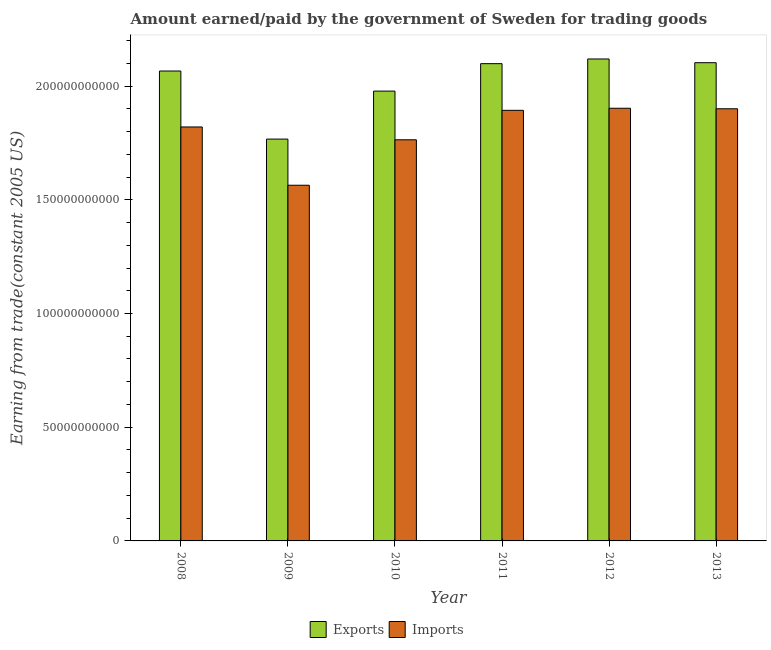How many different coloured bars are there?
Ensure brevity in your answer.  2. How many bars are there on the 5th tick from the right?
Your answer should be compact. 2. What is the label of the 6th group of bars from the left?
Keep it short and to the point. 2013. What is the amount earned from exports in 2010?
Give a very brief answer. 1.98e+11. Across all years, what is the maximum amount earned from exports?
Your answer should be very brief. 2.12e+11. Across all years, what is the minimum amount earned from exports?
Offer a very short reply. 1.77e+11. In which year was the amount earned from exports minimum?
Ensure brevity in your answer.  2009. What is the total amount earned from exports in the graph?
Make the answer very short. 1.21e+12. What is the difference between the amount earned from exports in 2011 and that in 2012?
Give a very brief answer. -2.06e+09. What is the difference between the amount paid for imports in 2012 and the amount earned from exports in 2009?
Make the answer very short. 3.39e+1. What is the average amount paid for imports per year?
Provide a succinct answer. 1.81e+11. In the year 2010, what is the difference between the amount paid for imports and amount earned from exports?
Give a very brief answer. 0. In how many years, is the amount paid for imports greater than 140000000000 US$?
Offer a terse response. 6. What is the ratio of the amount earned from exports in 2008 to that in 2009?
Ensure brevity in your answer.  1.17. Is the difference between the amount paid for imports in 2012 and 2013 greater than the difference between the amount earned from exports in 2012 and 2013?
Make the answer very short. No. What is the difference between the highest and the second highest amount paid for imports?
Provide a succinct answer. 2.25e+08. What is the difference between the highest and the lowest amount paid for imports?
Give a very brief answer. 3.39e+1. In how many years, is the amount paid for imports greater than the average amount paid for imports taken over all years?
Make the answer very short. 4. Is the sum of the amount earned from exports in 2009 and 2010 greater than the maximum amount paid for imports across all years?
Your response must be concise. Yes. What does the 1st bar from the left in 2009 represents?
Give a very brief answer. Exports. What does the 2nd bar from the right in 2009 represents?
Offer a very short reply. Exports. How many bars are there?
Offer a very short reply. 12. Are all the bars in the graph horizontal?
Make the answer very short. No. How many years are there in the graph?
Give a very brief answer. 6. Are the values on the major ticks of Y-axis written in scientific E-notation?
Provide a succinct answer. No. Does the graph contain any zero values?
Provide a succinct answer. No. Does the graph contain grids?
Keep it short and to the point. No. Where does the legend appear in the graph?
Your response must be concise. Bottom center. What is the title of the graph?
Give a very brief answer. Amount earned/paid by the government of Sweden for trading goods. What is the label or title of the Y-axis?
Your answer should be compact. Earning from trade(constant 2005 US). What is the Earning from trade(constant 2005 US) in Exports in 2008?
Keep it short and to the point. 2.07e+11. What is the Earning from trade(constant 2005 US) of Imports in 2008?
Offer a very short reply. 1.82e+11. What is the Earning from trade(constant 2005 US) in Exports in 2009?
Ensure brevity in your answer.  1.77e+11. What is the Earning from trade(constant 2005 US) in Imports in 2009?
Your answer should be very brief. 1.56e+11. What is the Earning from trade(constant 2005 US) of Exports in 2010?
Provide a succinct answer. 1.98e+11. What is the Earning from trade(constant 2005 US) of Imports in 2010?
Make the answer very short. 1.76e+11. What is the Earning from trade(constant 2005 US) in Exports in 2011?
Give a very brief answer. 2.10e+11. What is the Earning from trade(constant 2005 US) of Imports in 2011?
Provide a short and direct response. 1.89e+11. What is the Earning from trade(constant 2005 US) in Exports in 2012?
Make the answer very short. 2.12e+11. What is the Earning from trade(constant 2005 US) in Imports in 2012?
Give a very brief answer. 1.90e+11. What is the Earning from trade(constant 2005 US) in Exports in 2013?
Your answer should be compact. 2.10e+11. What is the Earning from trade(constant 2005 US) of Imports in 2013?
Offer a very short reply. 1.90e+11. Across all years, what is the maximum Earning from trade(constant 2005 US) of Exports?
Offer a terse response. 2.12e+11. Across all years, what is the maximum Earning from trade(constant 2005 US) in Imports?
Your response must be concise. 1.90e+11. Across all years, what is the minimum Earning from trade(constant 2005 US) in Exports?
Provide a succinct answer. 1.77e+11. Across all years, what is the minimum Earning from trade(constant 2005 US) in Imports?
Provide a succinct answer. 1.56e+11. What is the total Earning from trade(constant 2005 US) in Exports in the graph?
Provide a short and direct response. 1.21e+12. What is the total Earning from trade(constant 2005 US) of Imports in the graph?
Provide a short and direct response. 1.08e+12. What is the difference between the Earning from trade(constant 2005 US) of Exports in 2008 and that in 2009?
Give a very brief answer. 2.99e+1. What is the difference between the Earning from trade(constant 2005 US) in Imports in 2008 and that in 2009?
Keep it short and to the point. 2.56e+1. What is the difference between the Earning from trade(constant 2005 US) of Exports in 2008 and that in 2010?
Ensure brevity in your answer.  8.83e+09. What is the difference between the Earning from trade(constant 2005 US) of Imports in 2008 and that in 2010?
Provide a short and direct response. 5.64e+09. What is the difference between the Earning from trade(constant 2005 US) in Exports in 2008 and that in 2011?
Provide a succinct answer. -3.24e+09. What is the difference between the Earning from trade(constant 2005 US) in Imports in 2008 and that in 2011?
Your answer should be very brief. -7.31e+09. What is the difference between the Earning from trade(constant 2005 US) in Exports in 2008 and that in 2012?
Make the answer very short. -5.30e+09. What is the difference between the Earning from trade(constant 2005 US) in Imports in 2008 and that in 2012?
Offer a very short reply. -8.23e+09. What is the difference between the Earning from trade(constant 2005 US) in Exports in 2008 and that in 2013?
Offer a very short reply. -3.66e+09. What is the difference between the Earning from trade(constant 2005 US) of Imports in 2008 and that in 2013?
Make the answer very short. -8.00e+09. What is the difference between the Earning from trade(constant 2005 US) of Exports in 2009 and that in 2010?
Keep it short and to the point. -2.11e+1. What is the difference between the Earning from trade(constant 2005 US) in Imports in 2009 and that in 2010?
Offer a terse response. -2.00e+1. What is the difference between the Earning from trade(constant 2005 US) of Exports in 2009 and that in 2011?
Your answer should be compact. -3.32e+1. What is the difference between the Earning from trade(constant 2005 US) in Imports in 2009 and that in 2011?
Give a very brief answer. -3.29e+1. What is the difference between the Earning from trade(constant 2005 US) in Exports in 2009 and that in 2012?
Give a very brief answer. -3.52e+1. What is the difference between the Earning from trade(constant 2005 US) in Imports in 2009 and that in 2012?
Make the answer very short. -3.39e+1. What is the difference between the Earning from trade(constant 2005 US) in Exports in 2009 and that in 2013?
Your response must be concise. -3.36e+1. What is the difference between the Earning from trade(constant 2005 US) of Imports in 2009 and that in 2013?
Your answer should be very brief. -3.36e+1. What is the difference between the Earning from trade(constant 2005 US) of Exports in 2010 and that in 2011?
Provide a short and direct response. -1.21e+1. What is the difference between the Earning from trade(constant 2005 US) in Imports in 2010 and that in 2011?
Give a very brief answer. -1.30e+1. What is the difference between the Earning from trade(constant 2005 US) in Exports in 2010 and that in 2012?
Ensure brevity in your answer.  -1.41e+1. What is the difference between the Earning from trade(constant 2005 US) of Imports in 2010 and that in 2012?
Ensure brevity in your answer.  -1.39e+1. What is the difference between the Earning from trade(constant 2005 US) in Exports in 2010 and that in 2013?
Ensure brevity in your answer.  -1.25e+1. What is the difference between the Earning from trade(constant 2005 US) in Imports in 2010 and that in 2013?
Your response must be concise. -1.36e+1. What is the difference between the Earning from trade(constant 2005 US) of Exports in 2011 and that in 2012?
Your response must be concise. -2.06e+09. What is the difference between the Earning from trade(constant 2005 US) of Imports in 2011 and that in 2012?
Offer a very short reply. -9.13e+08. What is the difference between the Earning from trade(constant 2005 US) of Exports in 2011 and that in 2013?
Your response must be concise. -4.22e+08. What is the difference between the Earning from trade(constant 2005 US) of Imports in 2011 and that in 2013?
Provide a short and direct response. -6.88e+08. What is the difference between the Earning from trade(constant 2005 US) in Exports in 2012 and that in 2013?
Offer a terse response. 1.64e+09. What is the difference between the Earning from trade(constant 2005 US) in Imports in 2012 and that in 2013?
Give a very brief answer. 2.25e+08. What is the difference between the Earning from trade(constant 2005 US) of Exports in 2008 and the Earning from trade(constant 2005 US) of Imports in 2009?
Provide a short and direct response. 5.02e+1. What is the difference between the Earning from trade(constant 2005 US) in Exports in 2008 and the Earning from trade(constant 2005 US) in Imports in 2010?
Make the answer very short. 3.02e+1. What is the difference between the Earning from trade(constant 2005 US) in Exports in 2008 and the Earning from trade(constant 2005 US) in Imports in 2011?
Keep it short and to the point. 1.73e+1. What is the difference between the Earning from trade(constant 2005 US) of Exports in 2008 and the Earning from trade(constant 2005 US) of Imports in 2012?
Keep it short and to the point. 1.64e+1. What is the difference between the Earning from trade(constant 2005 US) of Exports in 2008 and the Earning from trade(constant 2005 US) of Imports in 2013?
Provide a short and direct response. 1.66e+1. What is the difference between the Earning from trade(constant 2005 US) in Exports in 2009 and the Earning from trade(constant 2005 US) in Imports in 2010?
Your answer should be compact. 3.08e+08. What is the difference between the Earning from trade(constant 2005 US) of Exports in 2009 and the Earning from trade(constant 2005 US) of Imports in 2011?
Your answer should be compact. -1.26e+1. What is the difference between the Earning from trade(constant 2005 US) of Exports in 2009 and the Earning from trade(constant 2005 US) of Imports in 2012?
Make the answer very short. -1.36e+1. What is the difference between the Earning from trade(constant 2005 US) of Exports in 2009 and the Earning from trade(constant 2005 US) of Imports in 2013?
Offer a terse response. -1.33e+1. What is the difference between the Earning from trade(constant 2005 US) of Exports in 2010 and the Earning from trade(constant 2005 US) of Imports in 2011?
Keep it short and to the point. 8.46e+09. What is the difference between the Earning from trade(constant 2005 US) of Exports in 2010 and the Earning from trade(constant 2005 US) of Imports in 2012?
Keep it short and to the point. 7.54e+09. What is the difference between the Earning from trade(constant 2005 US) of Exports in 2010 and the Earning from trade(constant 2005 US) of Imports in 2013?
Keep it short and to the point. 7.77e+09. What is the difference between the Earning from trade(constant 2005 US) of Exports in 2011 and the Earning from trade(constant 2005 US) of Imports in 2012?
Ensure brevity in your answer.  1.96e+1. What is the difference between the Earning from trade(constant 2005 US) of Exports in 2011 and the Earning from trade(constant 2005 US) of Imports in 2013?
Offer a terse response. 1.98e+1. What is the difference between the Earning from trade(constant 2005 US) of Exports in 2012 and the Earning from trade(constant 2005 US) of Imports in 2013?
Give a very brief answer. 2.19e+1. What is the average Earning from trade(constant 2005 US) in Exports per year?
Ensure brevity in your answer.  2.02e+11. What is the average Earning from trade(constant 2005 US) of Imports per year?
Provide a short and direct response. 1.81e+11. In the year 2008, what is the difference between the Earning from trade(constant 2005 US) of Exports and Earning from trade(constant 2005 US) of Imports?
Offer a terse response. 2.46e+1. In the year 2009, what is the difference between the Earning from trade(constant 2005 US) in Exports and Earning from trade(constant 2005 US) in Imports?
Keep it short and to the point. 2.03e+1. In the year 2010, what is the difference between the Earning from trade(constant 2005 US) in Exports and Earning from trade(constant 2005 US) in Imports?
Make the answer very short. 2.14e+1. In the year 2011, what is the difference between the Earning from trade(constant 2005 US) in Exports and Earning from trade(constant 2005 US) in Imports?
Provide a succinct answer. 2.05e+1. In the year 2012, what is the difference between the Earning from trade(constant 2005 US) of Exports and Earning from trade(constant 2005 US) of Imports?
Your response must be concise. 2.17e+1. In the year 2013, what is the difference between the Earning from trade(constant 2005 US) of Exports and Earning from trade(constant 2005 US) of Imports?
Offer a terse response. 2.03e+1. What is the ratio of the Earning from trade(constant 2005 US) in Exports in 2008 to that in 2009?
Your answer should be very brief. 1.17. What is the ratio of the Earning from trade(constant 2005 US) in Imports in 2008 to that in 2009?
Make the answer very short. 1.16. What is the ratio of the Earning from trade(constant 2005 US) of Exports in 2008 to that in 2010?
Your response must be concise. 1.04. What is the ratio of the Earning from trade(constant 2005 US) in Imports in 2008 to that in 2010?
Keep it short and to the point. 1.03. What is the ratio of the Earning from trade(constant 2005 US) of Exports in 2008 to that in 2011?
Provide a succinct answer. 0.98. What is the ratio of the Earning from trade(constant 2005 US) of Imports in 2008 to that in 2011?
Make the answer very short. 0.96. What is the ratio of the Earning from trade(constant 2005 US) in Imports in 2008 to that in 2012?
Make the answer very short. 0.96. What is the ratio of the Earning from trade(constant 2005 US) of Exports in 2008 to that in 2013?
Offer a terse response. 0.98. What is the ratio of the Earning from trade(constant 2005 US) in Imports in 2008 to that in 2013?
Keep it short and to the point. 0.96. What is the ratio of the Earning from trade(constant 2005 US) of Exports in 2009 to that in 2010?
Your answer should be very brief. 0.89. What is the ratio of the Earning from trade(constant 2005 US) in Imports in 2009 to that in 2010?
Provide a succinct answer. 0.89. What is the ratio of the Earning from trade(constant 2005 US) in Exports in 2009 to that in 2011?
Keep it short and to the point. 0.84. What is the ratio of the Earning from trade(constant 2005 US) in Imports in 2009 to that in 2011?
Offer a terse response. 0.83. What is the ratio of the Earning from trade(constant 2005 US) in Exports in 2009 to that in 2012?
Your answer should be very brief. 0.83. What is the ratio of the Earning from trade(constant 2005 US) in Imports in 2009 to that in 2012?
Your response must be concise. 0.82. What is the ratio of the Earning from trade(constant 2005 US) in Exports in 2009 to that in 2013?
Offer a very short reply. 0.84. What is the ratio of the Earning from trade(constant 2005 US) of Imports in 2009 to that in 2013?
Ensure brevity in your answer.  0.82. What is the ratio of the Earning from trade(constant 2005 US) in Exports in 2010 to that in 2011?
Provide a succinct answer. 0.94. What is the ratio of the Earning from trade(constant 2005 US) of Imports in 2010 to that in 2011?
Make the answer very short. 0.93. What is the ratio of the Earning from trade(constant 2005 US) of Imports in 2010 to that in 2012?
Ensure brevity in your answer.  0.93. What is the ratio of the Earning from trade(constant 2005 US) in Exports in 2010 to that in 2013?
Offer a terse response. 0.94. What is the ratio of the Earning from trade(constant 2005 US) of Imports in 2010 to that in 2013?
Give a very brief answer. 0.93. What is the ratio of the Earning from trade(constant 2005 US) in Exports in 2011 to that in 2012?
Keep it short and to the point. 0.99. What is the ratio of the Earning from trade(constant 2005 US) in Imports in 2011 to that in 2012?
Keep it short and to the point. 1. What is the ratio of the Earning from trade(constant 2005 US) in Imports in 2012 to that in 2013?
Offer a very short reply. 1. What is the difference between the highest and the second highest Earning from trade(constant 2005 US) of Exports?
Your response must be concise. 1.64e+09. What is the difference between the highest and the second highest Earning from trade(constant 2005 US) of Imports?
Make the answer very short. 2.25e+08. What is the difference between the highest and the lowest Earning from trade(constant 2005 US) in Exports?
Give a very brief answer. 3.52e+1. What is the difference between the highest and the lowest Earning from trade(constant 2005 US) of Imports?
Ensure brevity in your answer.  3.39e+1. 